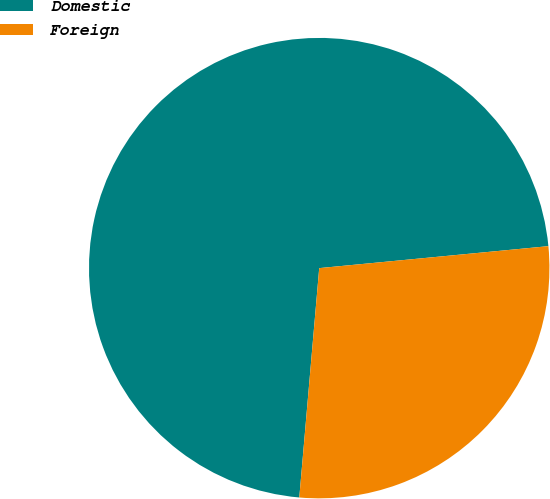Convert chart to OTSL. <chart><loc_0><loc_0><loc_500><loc_500><pie_chart><fcel>Domestic<fcel>Foreign<nl><fcel>72.1%<fcel>27.9%<nl></chart> 